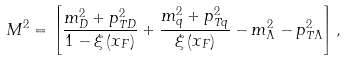<formula> <loc_0><loc_0><loc_500><loc_500>M ^ { 2 } = \left [ \frac { m _ { D } ^ { 2 } + p _ { T D } ^ { 2 } } { 1 - \xi \left ( x _ { F } \right ) } + \frac { m _ { q } ^ { 2 } + p _ { T q } ^ { 2 } } { \xi \left ( x _ { F } \right ) } - m _ { \Lambda } ^ { 2 } - p _ { T \Lambda } ^ { 2 } \right ] ,</formula> 